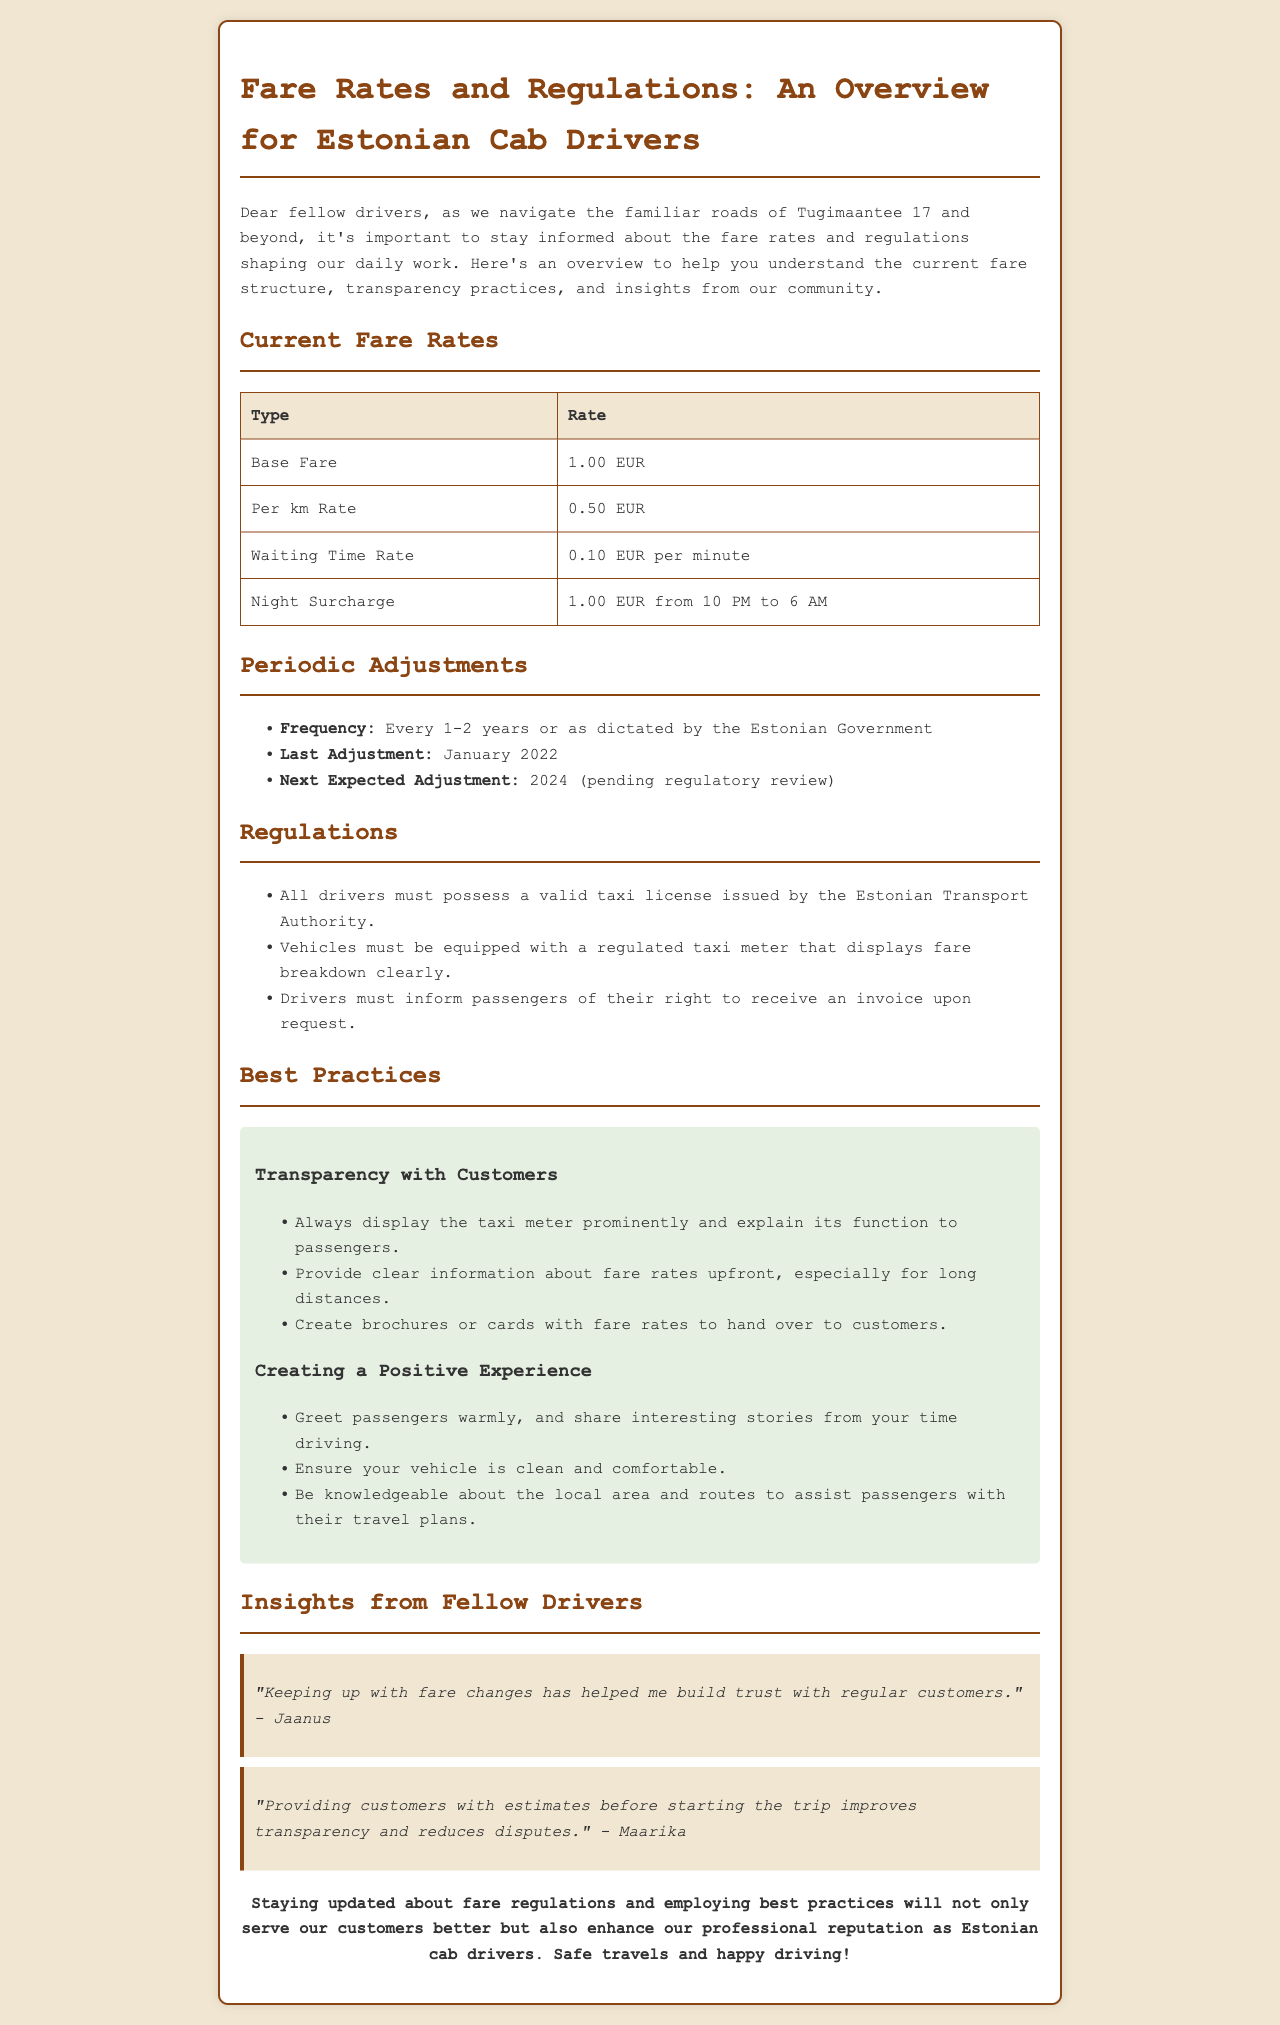what is the base fare? The base fare for cab drivers in Estonia is stated in the document as the initial charge for a ride.
Answer: 1.00 EUR what is the per km rate? The per kilometer rate is outlined in the document as the charge for distance travelled during a trip.
Answer: 0.50 EUR when was the last fare adjustment? The document specifies the timing of fare adjustments, indicating when the last change occurred.
Answer: January 2022 what time does the night surcharge apply? The document states specific hours during which the night surcharge is in effect.
Answer: 10 PM to 6 AM how often are fare rates adjusted? The document mentions the frequency of fare adjustments, providing clarity on how regularly they are updated.
Answer: Every 1-2 years who issues the taxi license? The document identifies the authority responsible for issuing taxi licenses to drivers in Estonia.
Answer: Estonian Transport Authority what is a best practice for transparency with customers? This suggests a recommended approach for cab drivers to enhance customer relations based on the document.
Answer: Display the taxi meter prominently who provided insights on keeping up with fare changes? The document features quotes from fellow drivers providing personal insights, identifying a contributor to the insights section.
Answer: Jaanus what was suggested to improve customer experience? The document includes recommendations for improving service quality for passengers to enhance their experience.
Answer: Ensure your vehicle is clean and comfortable 